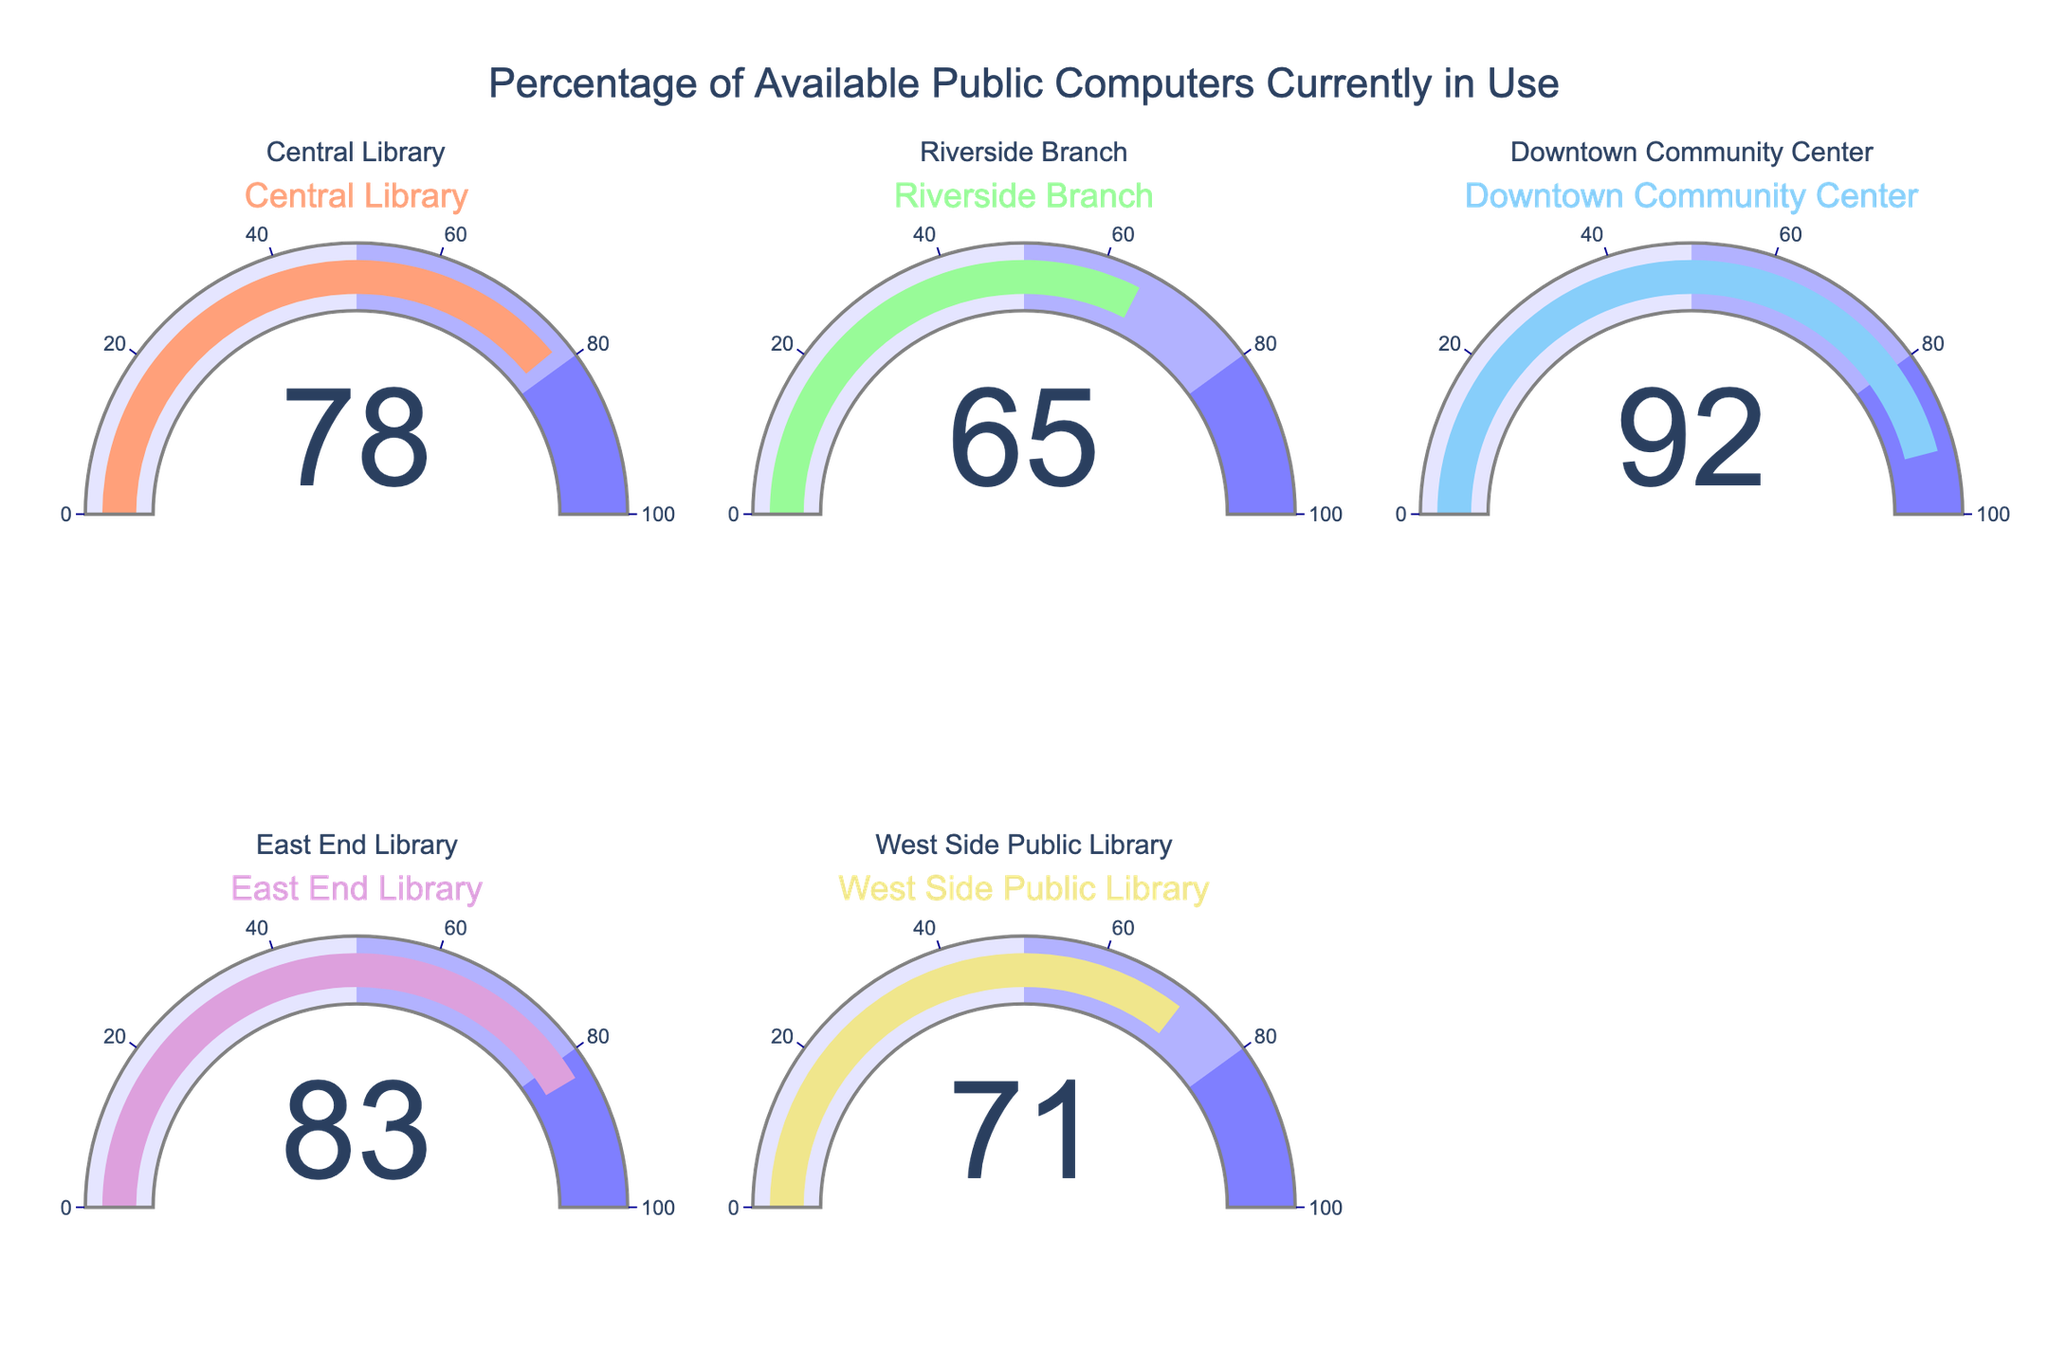what is the percentage of available public computers in use at the Downtown Community Center? By looking at the gauge chart for the Downtown Community Center, the percentage shown is 92%.
Answer: 92% Which library has the lowest percentage of available public computers in use? By evaluating each gauge chart, Riverside Branch has the lowest percentage at 65%.
Answer: Riverside Branch What are the combined percentages of available computers in use for Central Library and East End Library? Summing the percentages for Central Library (78%) and East End Library (83%) gives 78 + 83 = 161.
Answer: 161 What is the average percentage of available public computers currently in use across all libraries? Summing all percentages (78, 65, 92, 83, 71) and dividing by the number of libraries (5) gives (78+65+92+83+71)/5 = 77.8%.
Answer: 77.8% Is the percentage of available computers in use at any library over 90%? Which one? The gauge chart for the Downtown Community Center shows a percentage higher than 90%, specifically 92%.
Answer: Yes, Downtown Community Center Among all libraries, which one has the highest percentage of available public computers in use? Comparing all the gauge charts, the Downtown Community Center has the highest percentage at 92%.
Answer: Downtown Community Center What is the difference in percentage of available computers in use between the Central Library and the West Side Public Library? Subtracting West Side Public Library’s percentage (71%) from Central Library’s percentage (78%) gives 78 - 71 = 7.
Answer: 7 Which libraries have a percentage of available computers in use between 70% and 80%? Central Library (78%) and West Side Public Library (71%) fall in the 70%-80% range.
Answer: Central Library, West Side Public Library 